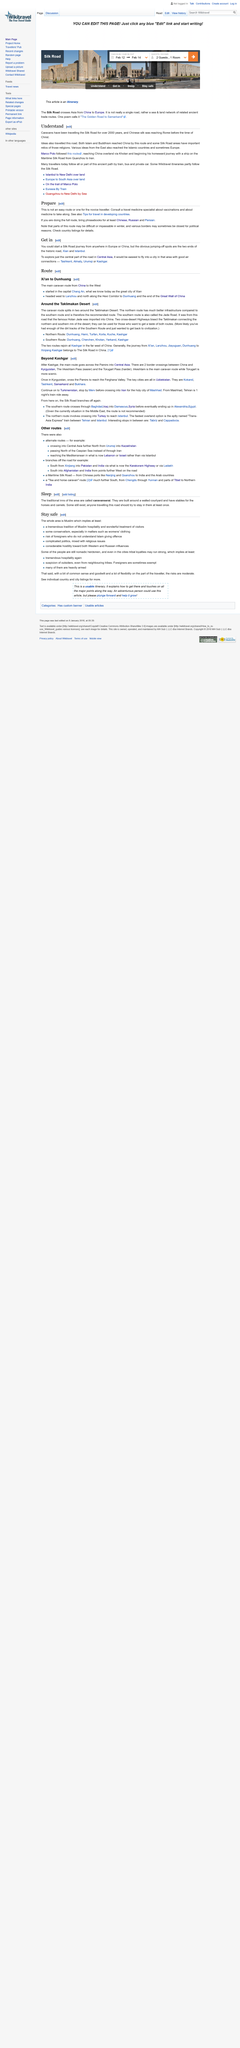Mention a couple of crucial points in this snapshot. Xian and Istanbul are the two cities that are located at the two ends of the Silk Road, an important trade route that was used for the exchange of goods and ideas between Asia and Europe during ancient times. Both Buddhism and Marco Polo traveled via the Silk Road. The cities of Tashkent, Almaty, Urumqi, and Kashgar are considered the best to fly into for accessing the Silk Road. It is advisable to start one's journey in either Europe or China and to carry Chinese, Russian, and Persian phrasebooks, as they will be useful in communicating with locals. The Silk Road is not a single road. 